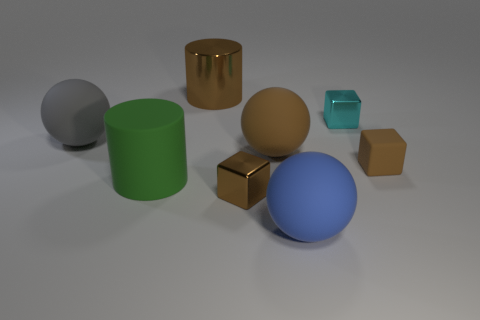Add 1 green matte objects. How many objects exist? 9 Subtract all spheres. How many objects are left? 5 Add 5 big things. How many big things exist? 10 Subtract 1 gray spheres. How many objects are left? 7 Subtract all large brown metallic things. Subtract all large brown shiny things. How many objects are left? 6 Add 3 large brown cylinders. How many large brown cylinders are left? 4 